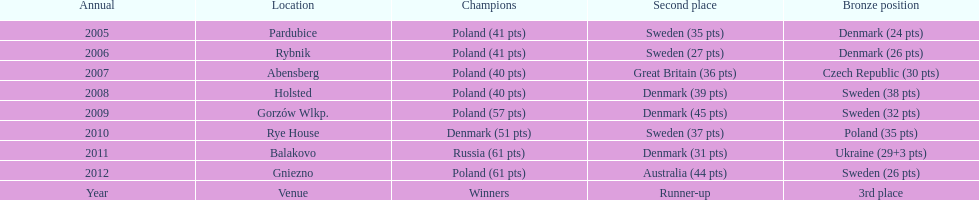After 2008 how many points total were scored by winners? 230. 